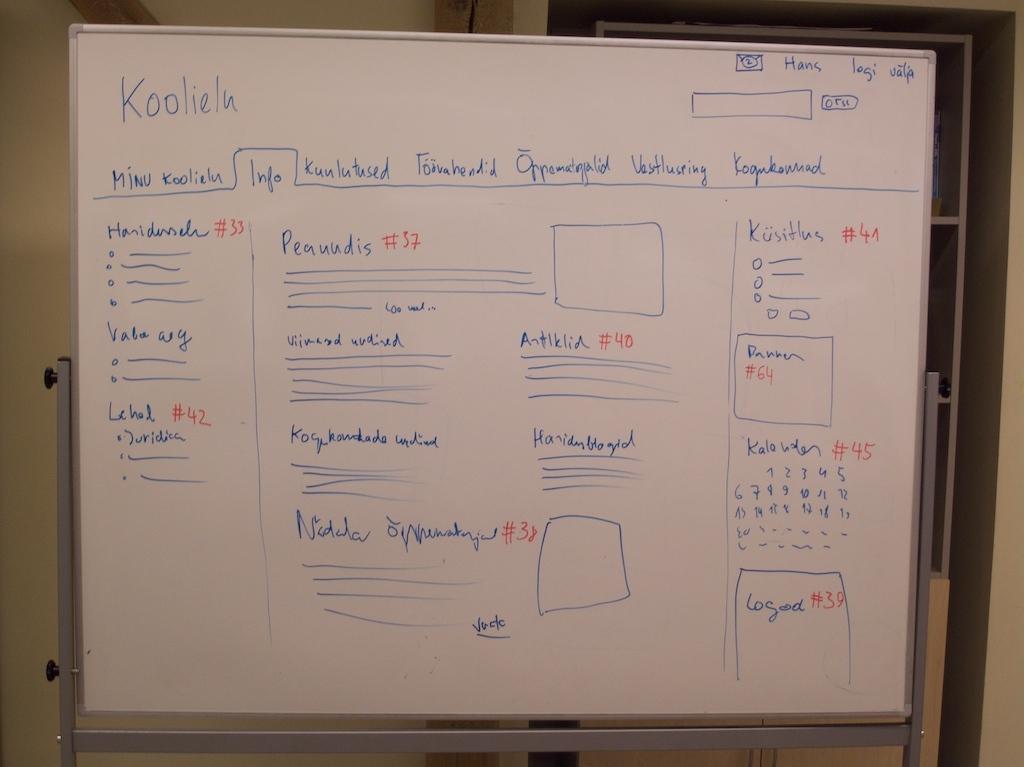What is the topic on the whiteboard?
Keep it short and to the point. Koolielu. 